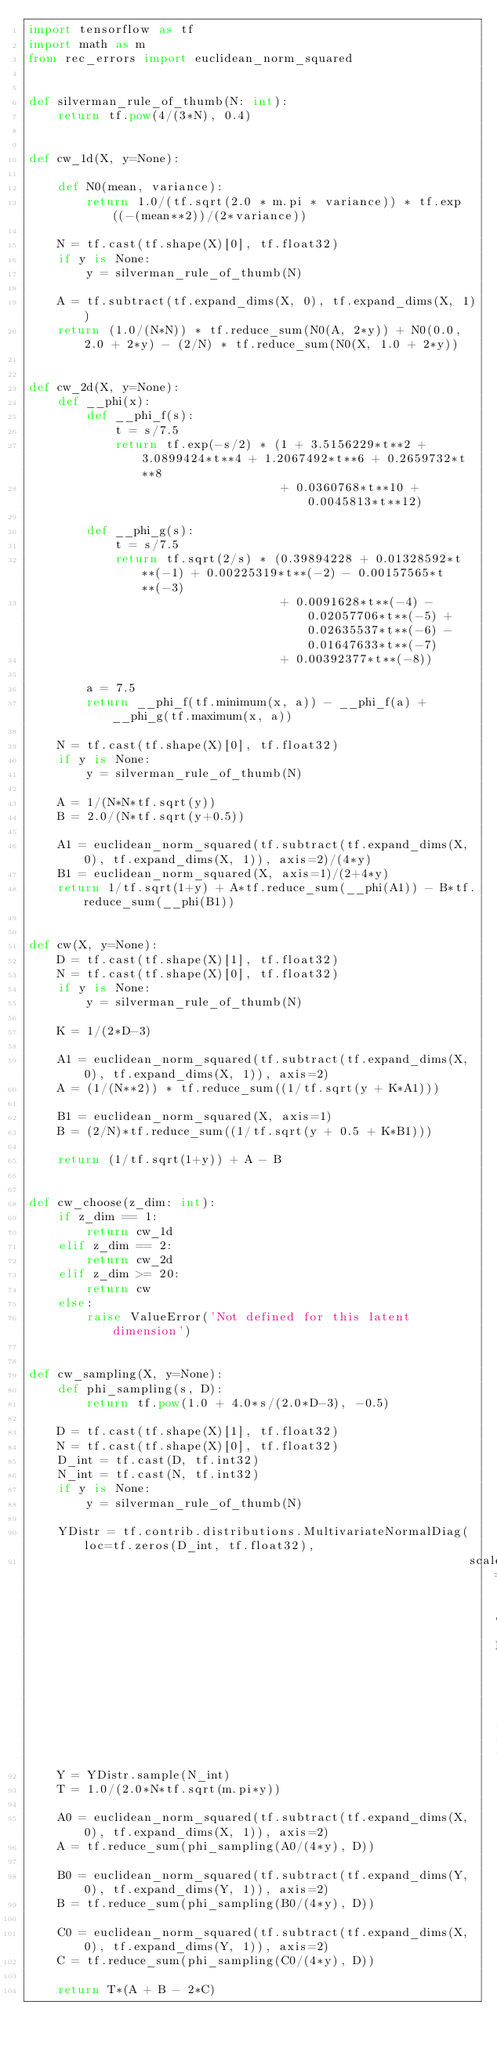<code> <loc_0><loc_0><loc_500><loc_500><_Python_>import tensorflow as tf
import math as m
from rec_errors import euclidean_norm_squared


def silverman_rule_of_thumb(N: int):
    return tf.pow(4/(3*N), 0.4)


def cw_1d(X, y=None):

    def N0(mean, variance):
        return 1.0/(tf.sqrt(2.0 * m.pi * variance)) * tf.exp((-(mean**2))/(2*variance))

    N = tf.cast(tf.shape(X)[0], tf.float32)
    if y is None:
        y = silverman_rule_of_thumb(N)

    A = tf.subtract(tf.expand_dims(X, 0), tf.expand_dims(X, 1))
    return (1.0/(N*N)) * tf.reduce_sum(N0(A, 2*y)) + N0(0.0, 2.0 + 2*y) - (2/N) * tf.reduce_sum(N0(X, 1.0 + 2*y))


def cw_2d(X, y=None):
    def __phi(x):
        def __phi_f(s):
            t = s/7.5
            return tf.exp(-s/2) * (1 + 3.5156229*t**2 + 3.0899424*t**4 + 1.2067492*t**6 + 0.2659732*t**8
                                   + 0.0360768*t**10 + 0.0045813*t**12)

        def __phi_g(s):
            t = s/7.5
            return tf.sqrt(2/s) * (0.39894228 + 0.01328592*t**(-1) + 0.00225319*t**(-2) - 0.00157565*t**(-3)
                                   + 0.0091628*t**(-4) - 0.02057706*t**(-5) + 0.02635537*t**(-6) - 0.01647633*t**(-7)
                                   + 0.00392377*t**(-8))

        a = 7.5
        return __phi_f(tf.minimum(x, a)) - __phi_f(a) + __phi_g(tf.maximum(x, a))

    N = tf.cast(tf.shape(X)[0], tf.float32)
    if y is None:
        y = silverman_rule_of_thumb(N)

    A = 1/(N*N*tf.sqrt(y))
    B = 2.0/(N*tf.sqrt(y+0.5))

    A1 = euclidean_norm_squared(tf.subtract(tf.expand_dims(X, 0), tf.expand_dims(X, 1)), axis=2)/(4*y)
    B1 = euclidean_norm_squared(X, axis=1)/(2+4*y)
    return 1/tf.sqrt(1+y) + A*tf.reduce_sum(__phi(A1)) - B*tf.reduce_sum(__phi(B1))


def cw(X, y=None):
    D = tf.cast(tf.shape(X)[1], tf.float32)
    N = tf.cast(tf.shape(X)[0], tf.float32)
    if y is None:
        y = silverman_rule_of_thumb(N)

    K = 1/(2*D-3)

    A1 = euclidean_norm_squared(tf.subtract(tf.expand_dims(X, 0), tf.expand_dims(X, 1)), axis=2)
    A = (1/(N**2)) * tf.reduce_sum((1/tf.sqrt(y + K*A1)))

    B1 = euclidean_norm_squared(X, axis=1)
    B = (2/N)*tf.reduce_sum((1/tf.sqrt(y + 0.5 + K*B1)))

    return (1/tf.sqrt(1+y)) + A - B


def cw_choose(z_dim: int):
    if z_dim == 1:
        return cw_1d
    elif z_dim == 2:
        return cw_2d
    elif z_dim >= 20:
        return cw
    else:
        raise ValueError('Not defined for this latent dimension')


def cw_sampling(X, y=None):
    def phi_sampling(s, D):
        return tf.pow(1.0 + 4.0*s/(2.0*D-3), -0.5)

    D = tf.cast(tf.shape(X)[1], tf.float32)
    N = tf.cast(tf.shape(X)[0], tf.float32)
    D_int = tf.cast(D, tf.int32)
    N_int = tf.cast(N, tf.int32)
    if y is None:
        y = silverman_rule_of_thumb(N)

    YDistr = tf.contrib.distributions.MultivariateNormalDiag(loc=tf.zeros(D_int, tf.float32), 
                                                             scale_diag=tf.ones(D_int, tf.float32))
    Y = YDistr.sample(N_int)
    T = 1.0/(2.0*N*tf.sqrt(m.pi*y))

    A0 = euclidean_norm_squared(tf.subtract(tf.expand_dims(X, 0), tf.expand_dims(X, 1)), axis=2)
    A = tf.reduce_sum(phi_sampling(A0/(4*y), D))

    B0 = euclidean_norm_squared(tf.subtract(tf.expand_dims(Y, 0), tf.expand_dims(Y, 1)), axis=2)
    B = tf.reduce_sum(phi_sampling(B0/(4*y), D))

    C0 = euclidean_norm_squared(tf.subtract(tf.expand_dims(X, 0), tf.expand_dims(Y, 1)), axis=2)
    C = tf.reduce_sum(phi_sampling(C0/(4*y), D))

    return T*(A + B - 2*C)
</code> 